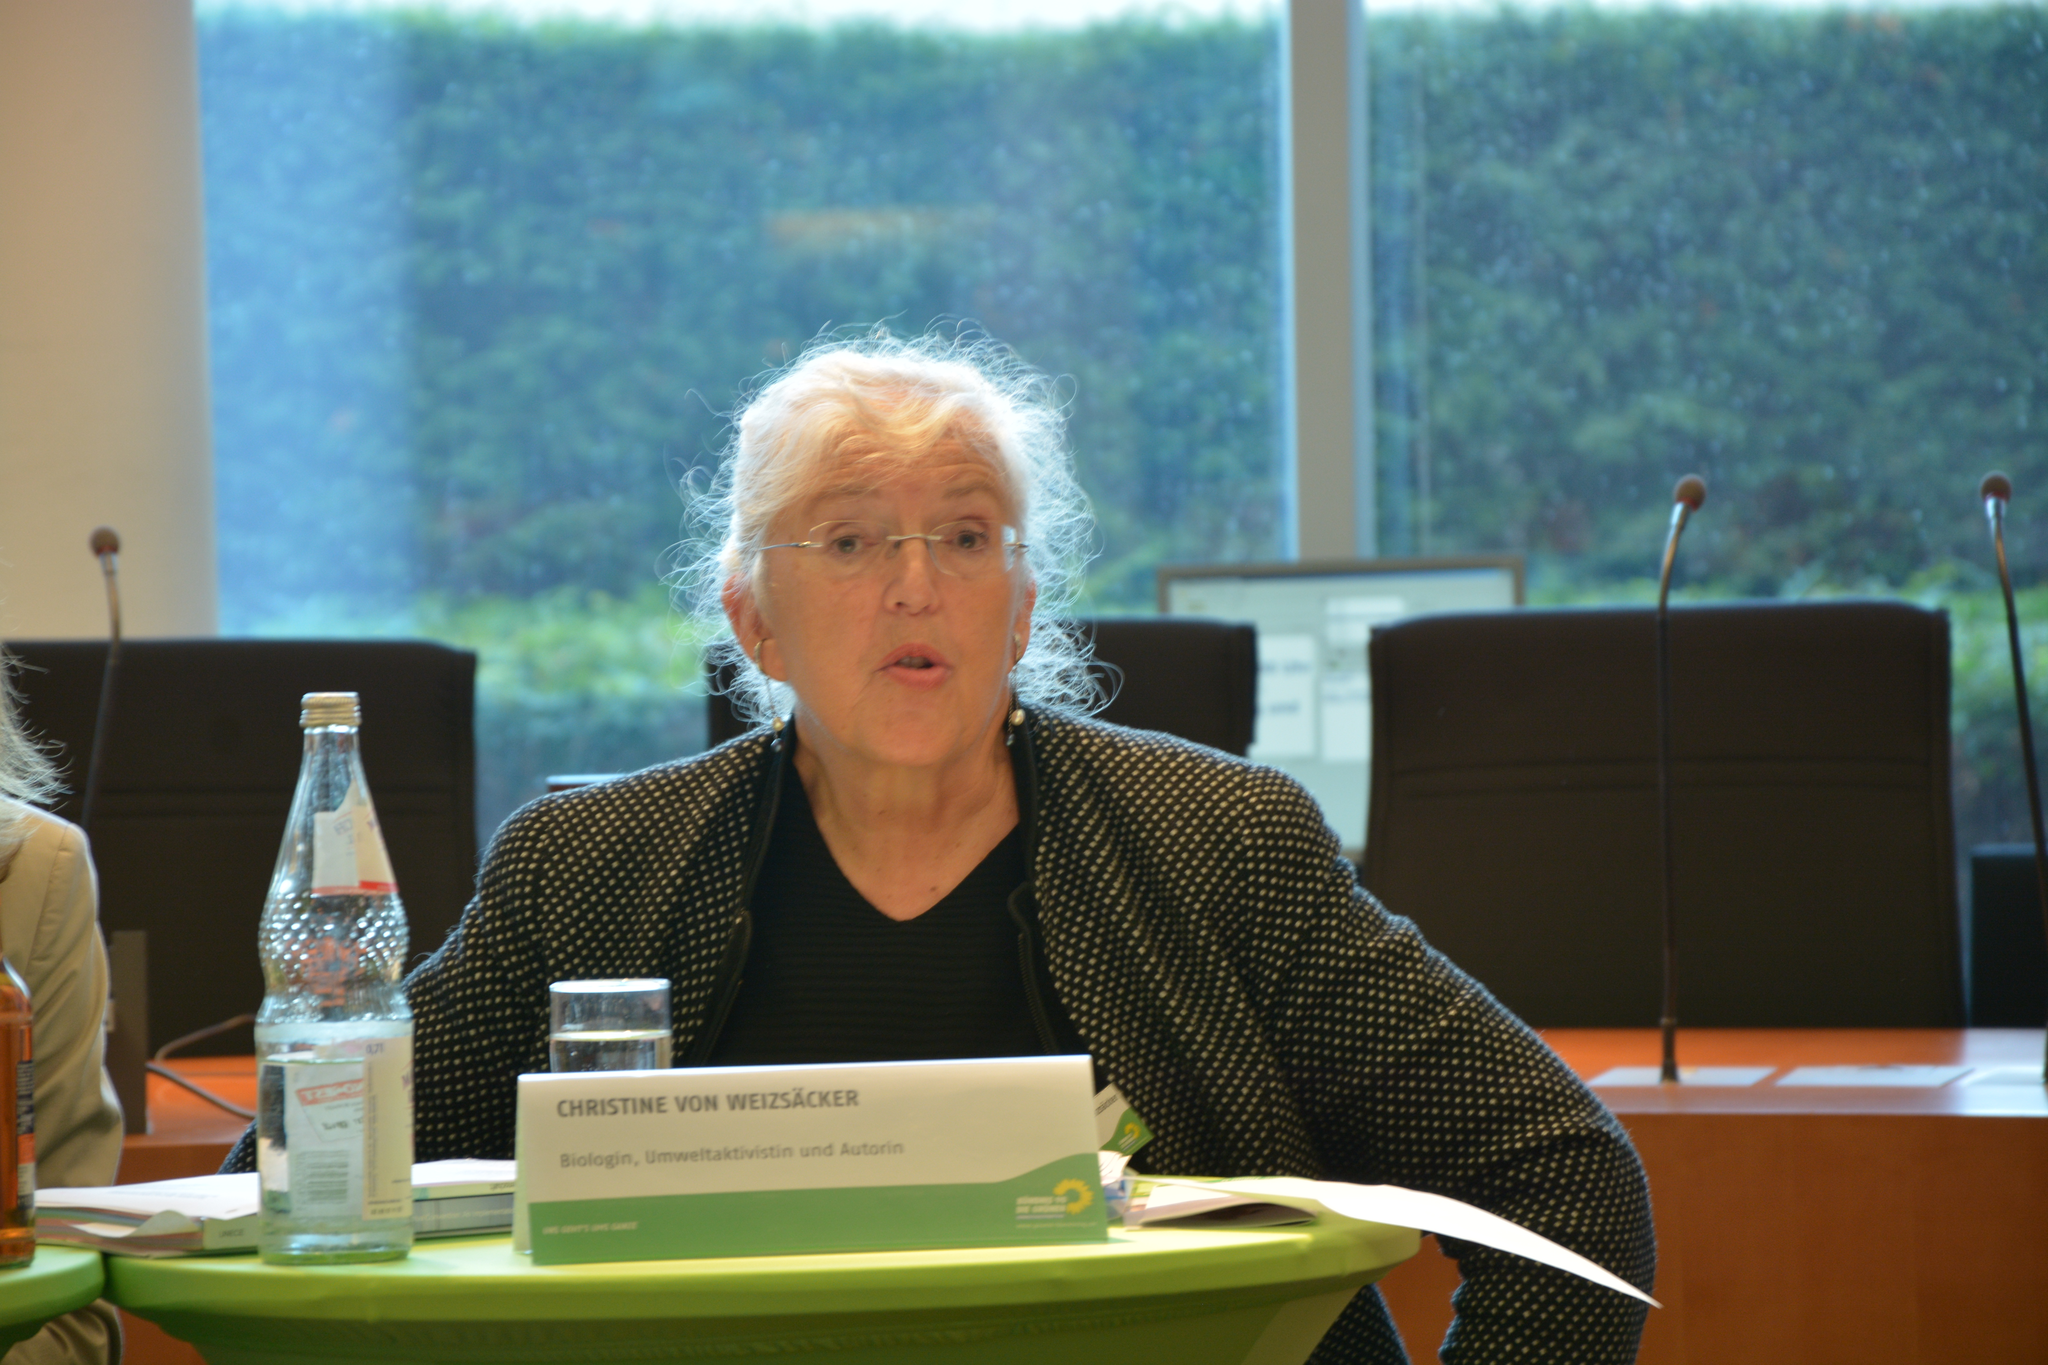<image>
Provide a brief description of the given image. An older nady whose name is Christine von Weizsacker 